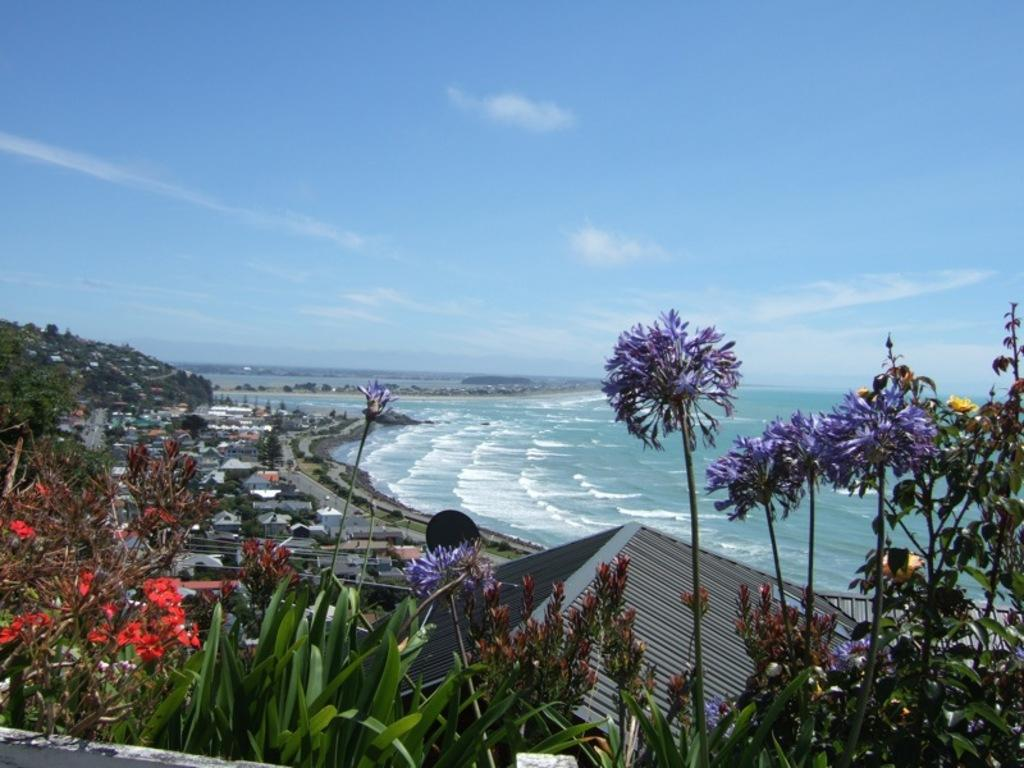What is the primary element visible in the image? There is water in the image. What type of structures can be seen in the image? There are buildings in the image. What type of vegetation is present in the image? There are plants with flowers and grass in the image. What is visible in the background of the image? The sky is visible in the image, and clouds are present in the sky. What type of tramp can be seen bouncing on the rhythm in the image? There is no tramp or rhythm present in the image; it features water, buildings, plants, grass, and the sky. 